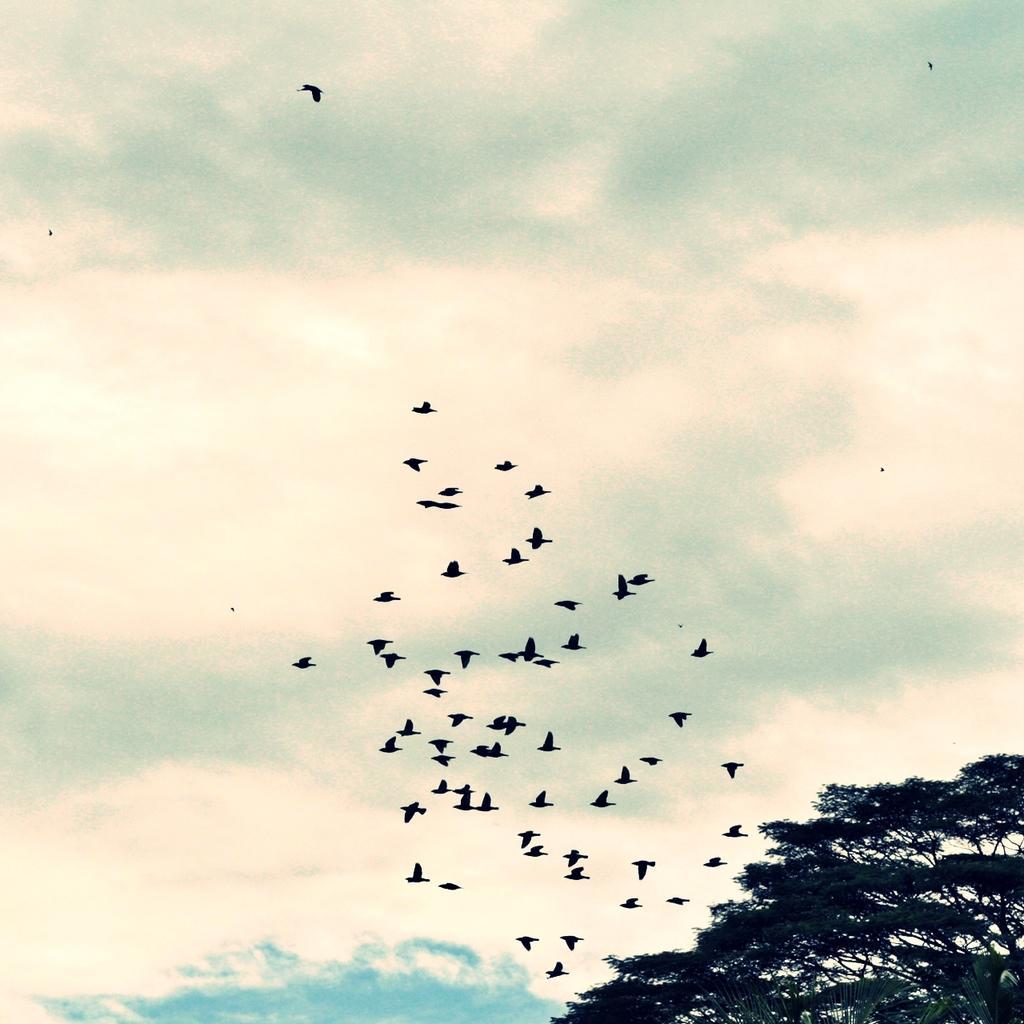Describe this image in one or two sentences. Here we can see birds flying in the air. There are trees. In the background there is sky. 